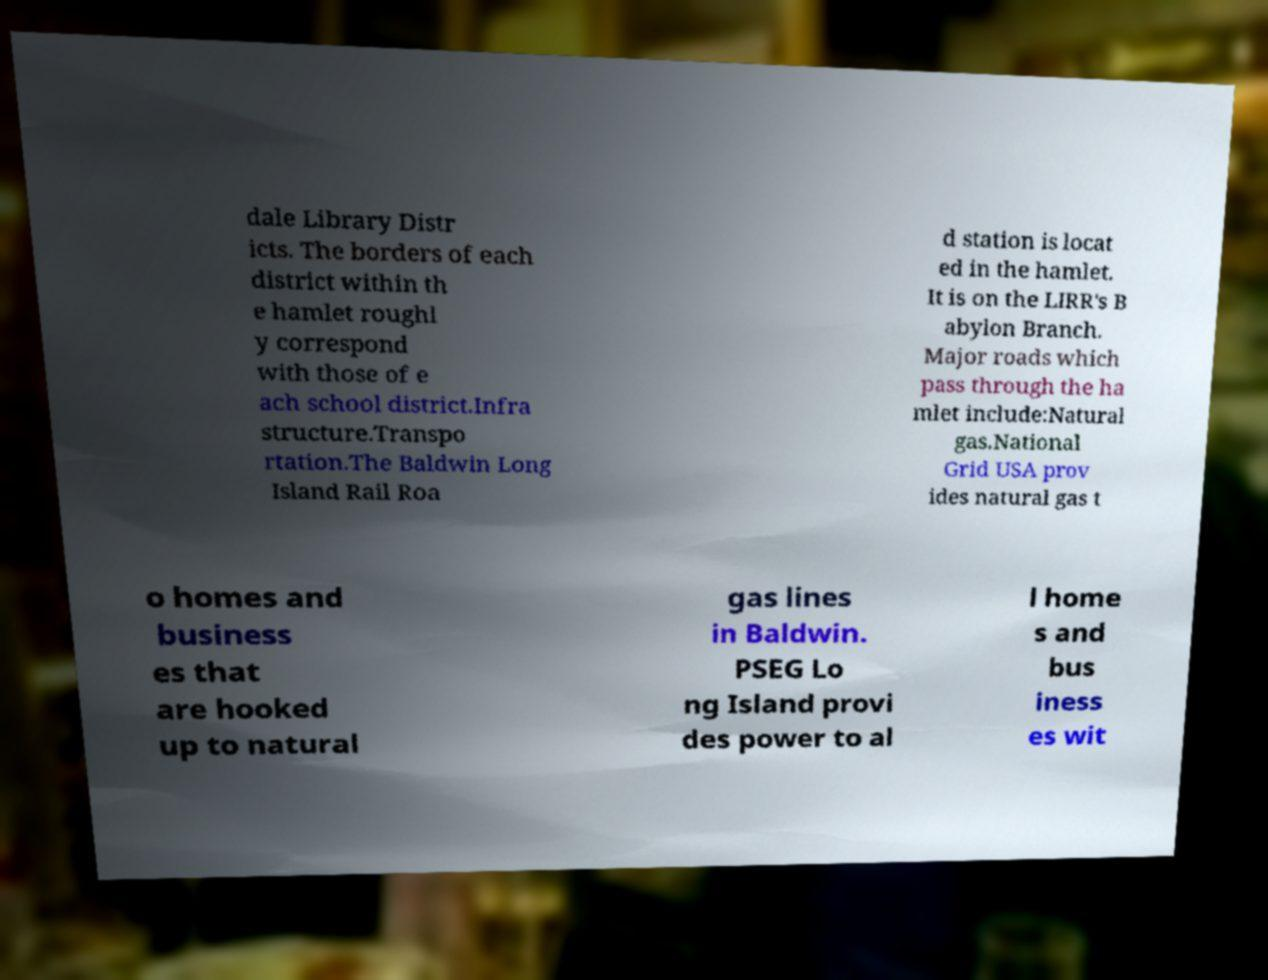There's text embedded in this image that I need extracted. Can you transcribe it verbatim? dale Library Distr icts. The borders of each district within th e hamlet roughl y correspond with those of e ach school district.Infra structure.Transpo rtation.The Baldwin Long Island Rail Roa d station is locat ed in the hamlet. It is on the LIRR's B abylon Branch. Major roads which pass through the ha mlet include:Natural gas.National Grid USA prov ides natural gas t o homes and business es that are hooked up to natural gas lines in Baldwin. PSEG Lo ng Island provi des power to al l home s and bus iness es wit 